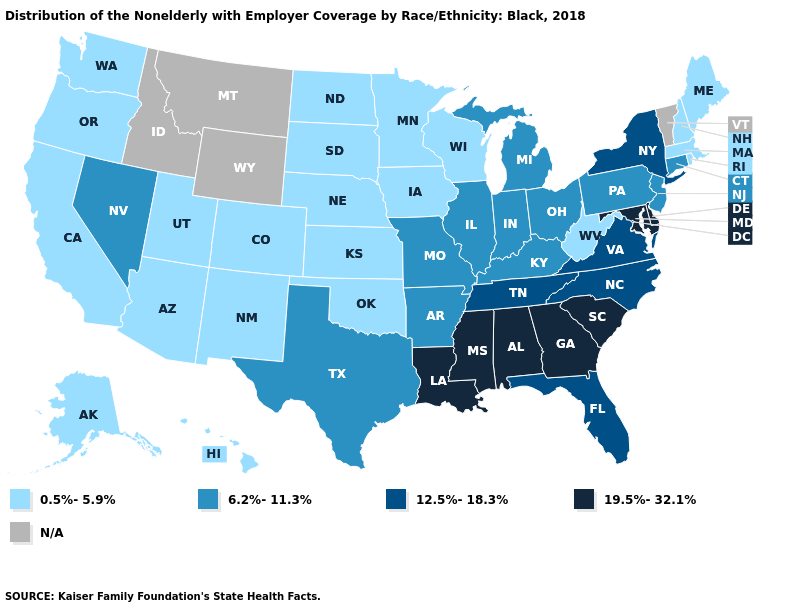Among the states that border Massachusetts , does Rhode Island have the highest value?
Keep it brief. No. Name the states that have a value in the range 19.5%-32.1%?
Short answer required. Alabama, Delaware, Georgia, Louisiana, Maryland, Mississippi, South Carolina. Does the first symbol in the legend represent the smallest category?
Quick response, please. Yes. What is the value of North Dakota?
Give a very brief answer. 0.5%-5.9%. What is the value of Maryland?
Quick response, please. 19.5%-32.1%. How many symbols are there in the legend?
Answer briefly. 5. What is the value of West Virginia?
Keep it brief. 0.5%-5.9%. What is the value of Ohio?
Be succinct. 6.2%-11.3%. Does New Hampshire have the lowest value in the USA?
Be succinct. Yes. What is the value of New Hampshire?
Be succinct. 0.5%-5.9%. What is the value of New Hampshire?
Concise answer only. 0.5%-5.9%. What is the value of North Carolina?
Answer briefly. 12.5%-18.3%. What is the highest value in the Northeast ?
Concise answer only. 12.5%-18.3%. Among the states that border Arkansas , which have the highest value?
Short answer required. Louisiana, Mississippi. Does the first symbol in the legend represent the smallest category?
Answer briefly. Yes. 